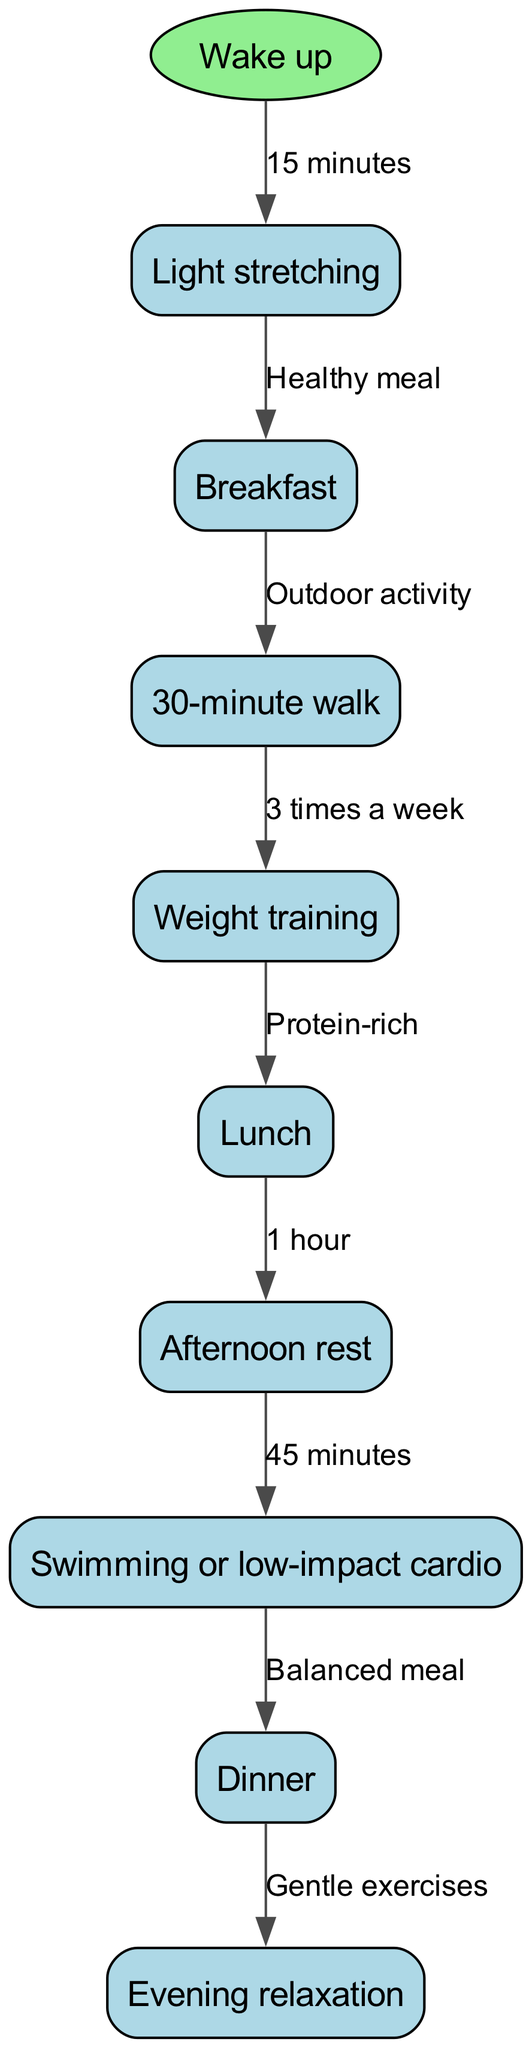What is the starting point of the daily workout routine? The starting point is indicated as "Wake up" in the diagram. It's the first node from which all activities proceed.
Answer: Wake up How many nodes are there in the flow chart? The nodes in the diagram represent distinct activities. There are a total of 9 nodes including the starting point.
Answer: 9 What activity follows "Lunch" in the flow chart? The activity that follows "Lunch" is "Afternoon rest," according to the directional flows shown in the diagram.
Answer: Afternoon rest How long is the "Light stretching" activity? The diagram specifies that "Light stretching" takes 15 minutes as shown by the label on the connecting edge from "Wake up."
Answer: 15 minutes What type of meal is suggested after "Weight training"? The diagram indicates "Lunch" as a protein-rich meal following "Weight training" in the flow of activities.
Answer: Protein-rich How many times a week is "Weight training" performed? The diagram denotes that "Weight training" is performed 3 times a week, as indicated on the edge connecting from "30-minute walk" to "Weight training."
Answer: 3 times a week What is the final activity in the daily workout routine? The flow chart concludes with "Evening relaxation" as the last node in the sequence of activities.
Answer: Evening relaxation What duration is allocated for "Swimming or low-impact cardio"? The diagram states "Swimming or low-impact cardio" lasts for 45 minutes, as shown on the edge leading to the next activity.
Answer: 45 minutes What is the connection between "Dinner" and "Evening relaxation"? The edge between "Dinner" and "Evening relaxation" indicates a transition to gentle exercises after dinner.
Answer: Gentle exercises 